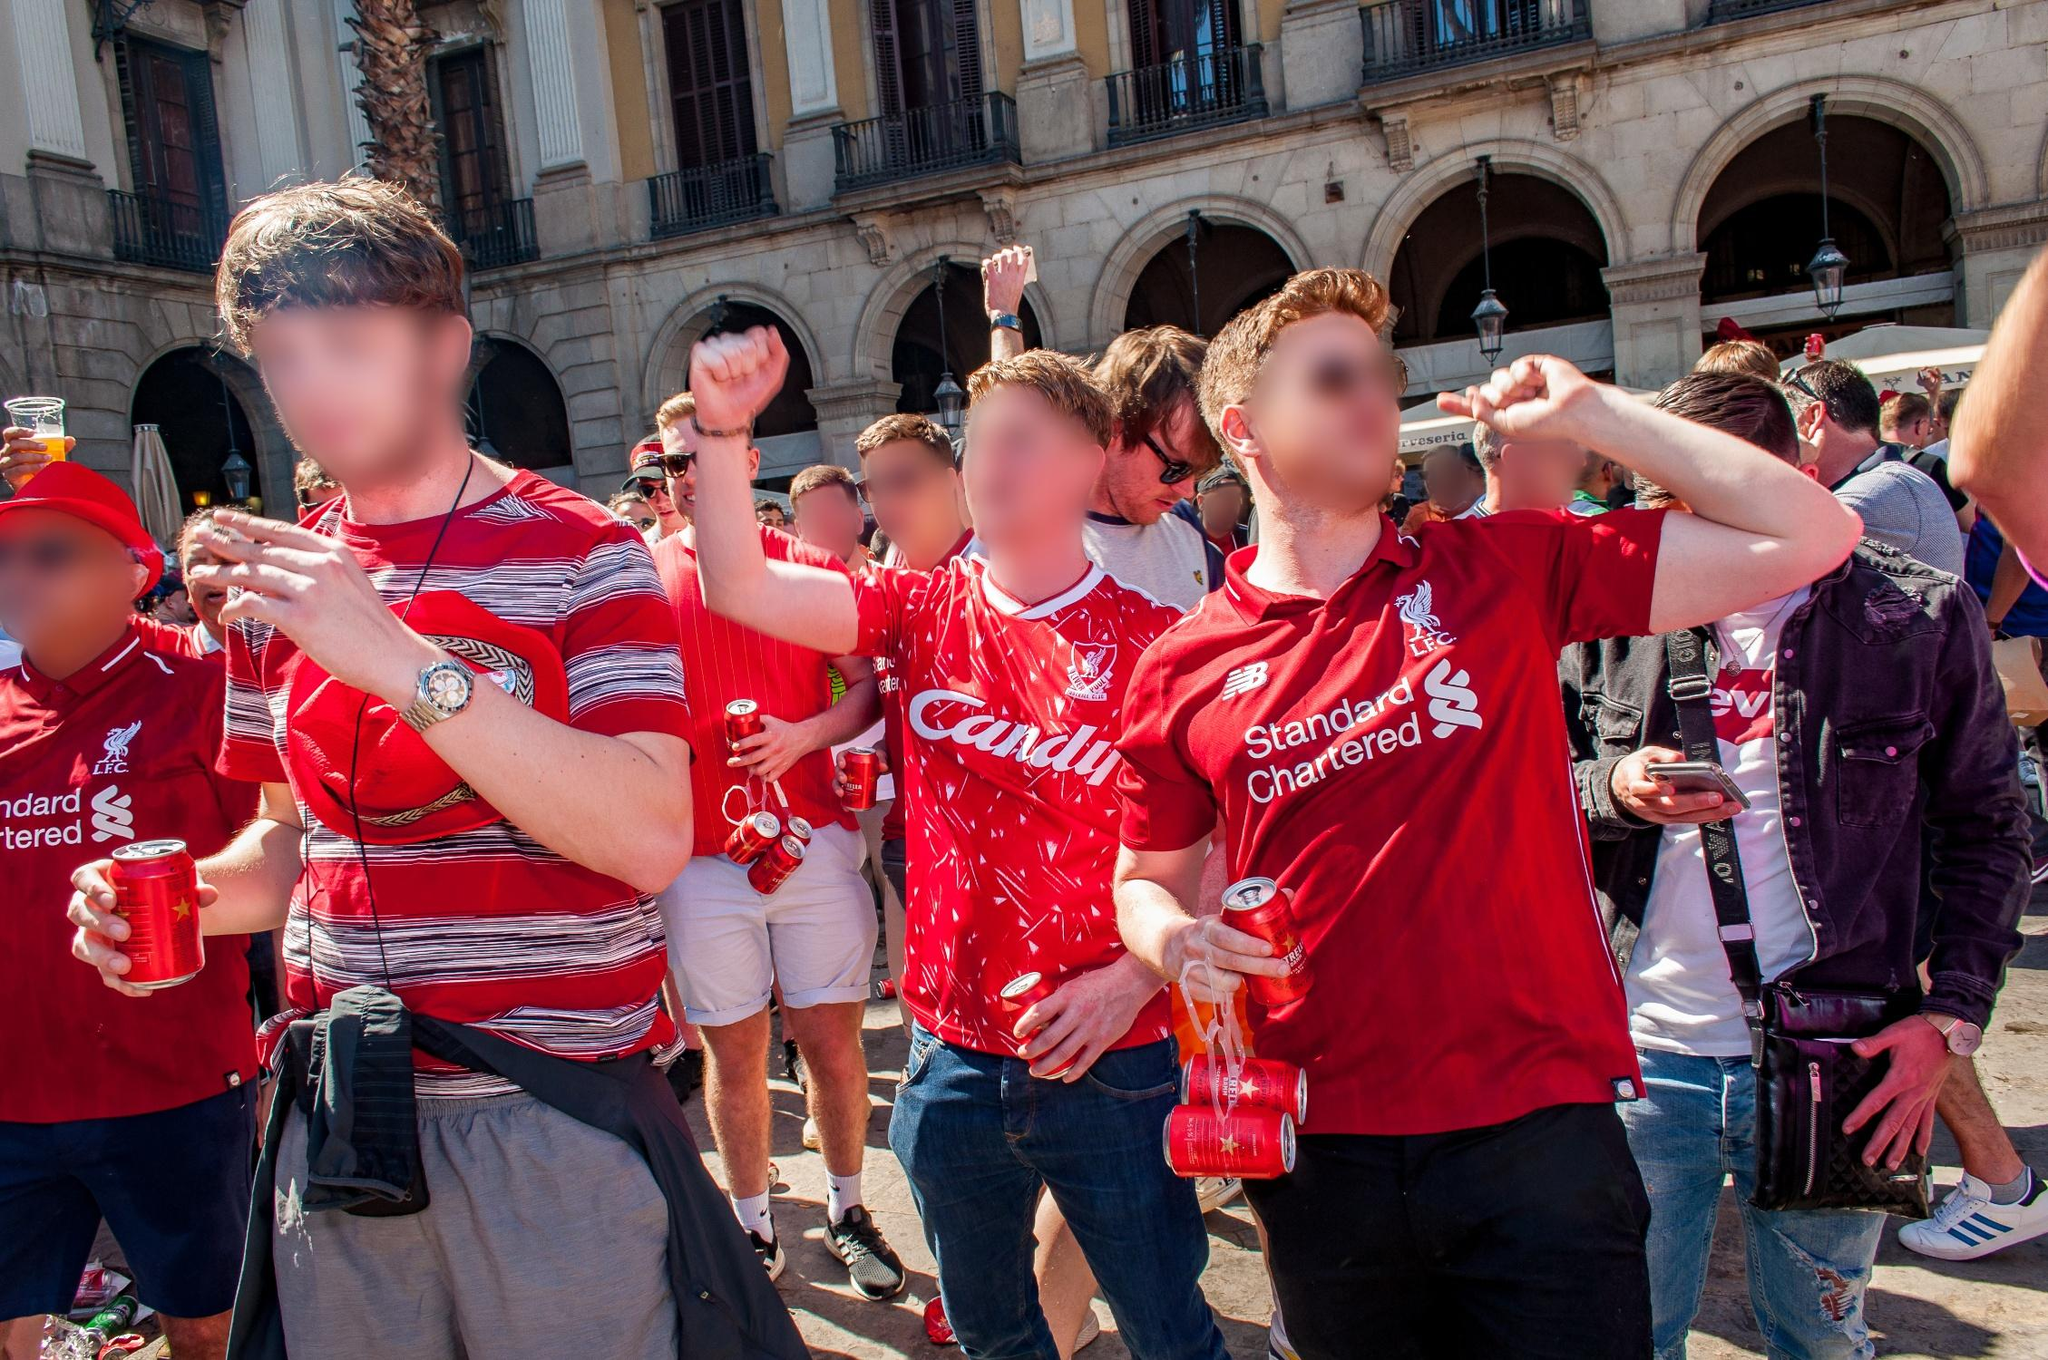Who are these people, and what might they represent? These individuals appear to be fans or supporters of a sports team, given their matching red shirts adorned with logos and designs such as 'Candil' and 'Standard Chartered'. They likely represent a community of supporters who have gathered to revel in a shared moment of victory or celebration. Their collective enthusiasm and presence in front of a historic European-style building create a vivid image of unity and shared joy. What architectural style does the building in the background represent? The building in the background exemplifies historic European architecture, characterized by its grand arches and columns. This style often features elements like ornate stonework, intricate detailing, and symmetrical design, all of which can be seen in the structure behind the celebrating crowd. Such architectural designs are usually associated with a sense of grandeur and historical significance. Imagine the sharegpt4v/same scene but set in the year 3023. Describe the advanced technologies or elements that might be present. In the year 3023, this scene might be transformed by advanced technologies and futuristic elements. The people might be wearing high-tech smart clothing that changes color and display information or holograms, enhancing their celebratory spirit. The historic building could be augmented with holographic projections, displaying vibrant digital art or advertisements. Drones might be hovering around, capturing the celebration from various angles, broadcasting live feeds to global audiences through augmented reality headsets. Drinks could be served in smart containers that track hydration levels and provide nutritional information. The overall atmosphere would be a blend of historic charm and cutting-edge innovation, reflecting humanity's progress while celebrating timeless traditions. What realistic scenario could this celebration be part of? This celebration could realistically be a part of a major sporting event, such as a football championship. The people in the photo are likely supporters who have come together to celebrate their team's victory in a grand location that adds to the significance of the event. Their matching shirts and the logos they display indicate a strong sense of community and team spirit, which are often central to such large gatherings. Describe a shorter realistic scenario. This scene could be from a post-match celebration where fans have gathered outside a historic stadium to revel in their team’s recent win. The location adds a sense of grandeur to their joyous gathering. 